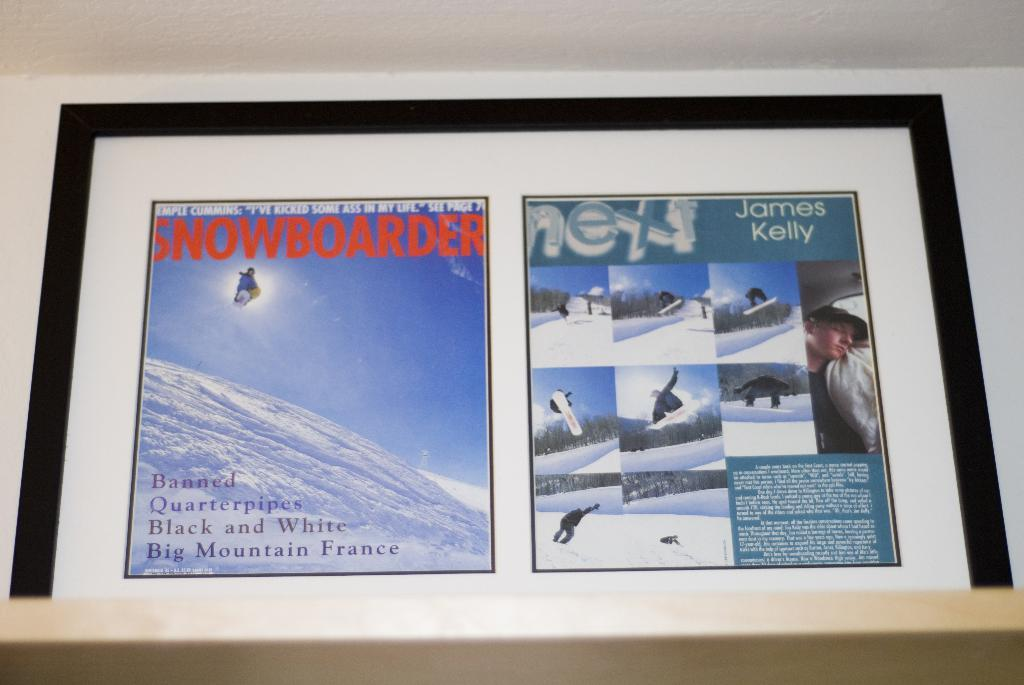<image>
Render a clear and concise summary of the photo. Framed pages of Snowboarder magazine including the cover. 